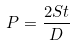Convert formula to latex. <formula><loc_0><loc_0><loc_500><loc_500>P = \frac { 2 S t } { D }</formula> 